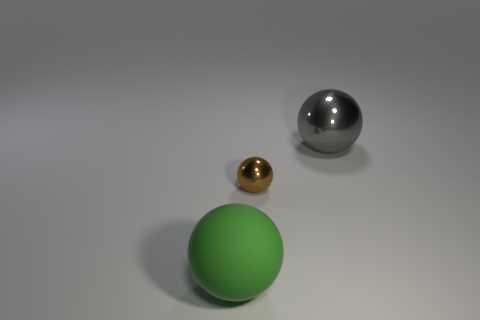Add 2 small purple cubes. How many objects exist? 5 Add 2 gray spheres. How many gray spheres exist? 3 Subtract 0 red cylinders. How many objects are left? 3 Subtract all tiny brown things. Subtract all large objects. How many objects are left? 0 Add 1 shiny spheres. How many shiny spheres are left? 3 